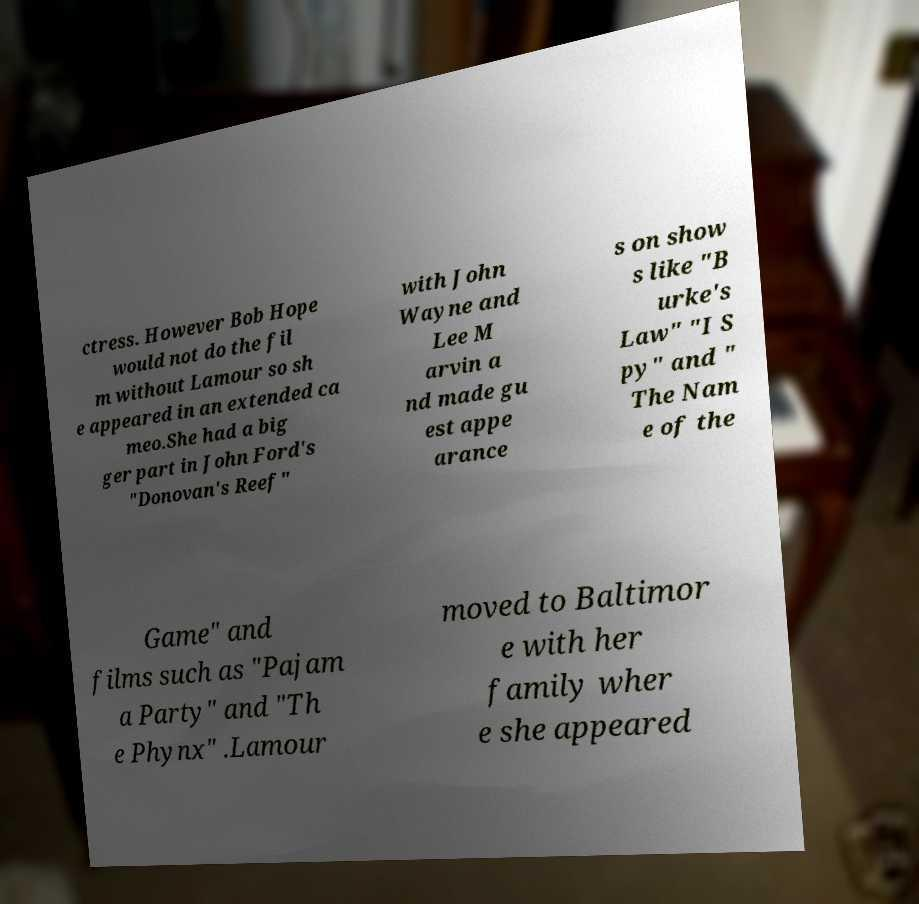What messages or text are displayed in this image? I need them in a readable, typed format. ctress. However Bob Hope would not do the fil m without Lamour so sh e appeared in an extended ca meo.She had a big ger part in John Ford's "Donovan's Reef" with John Wayne and Lee M arvin a nd made gu est appe arance s on show s like "B urke's Law" "I S py" and " The Nam e of the Game" and films such as "Pajam a Party" and "Th e Phynx" .Lamour moved to Baltimor e with her family wher e she appeared 